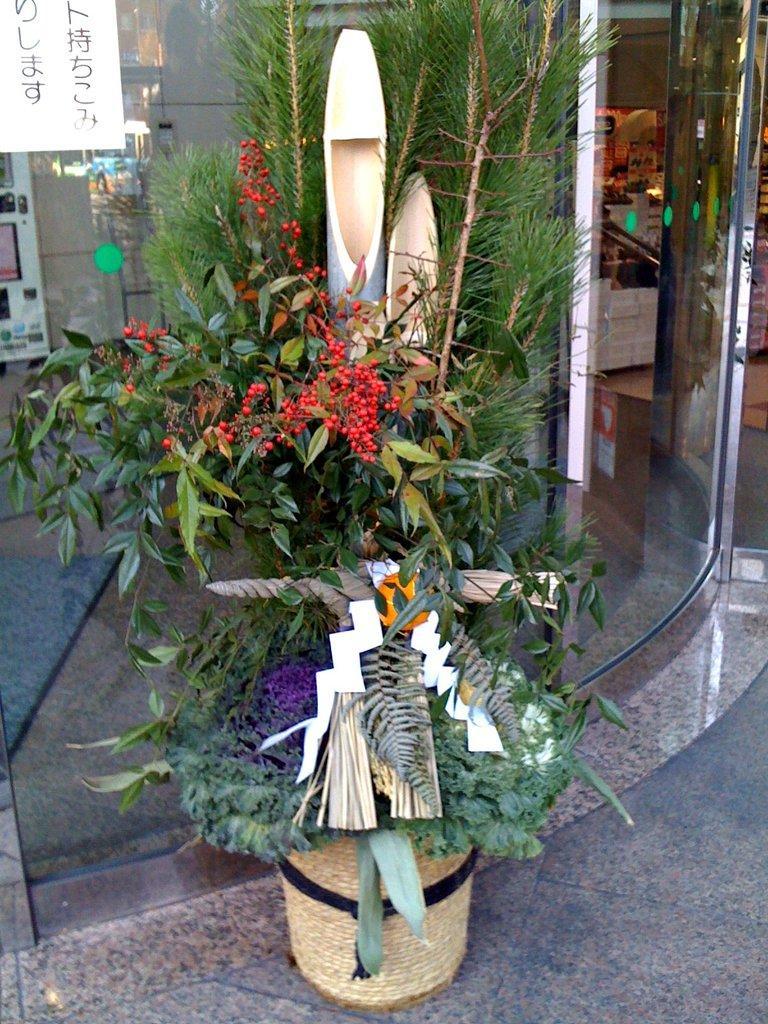Could you give a brief overview of what you see in this image? In this image we can see the floor. And we can see the plants. And some objects on the plant. And we can see some reflections on the glass. 